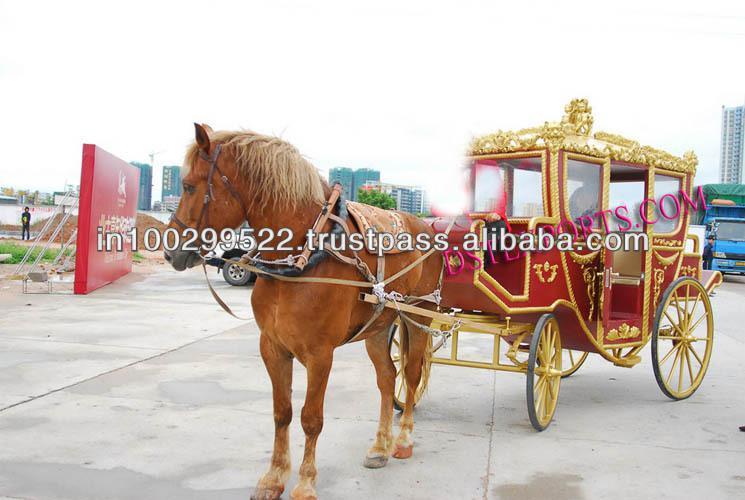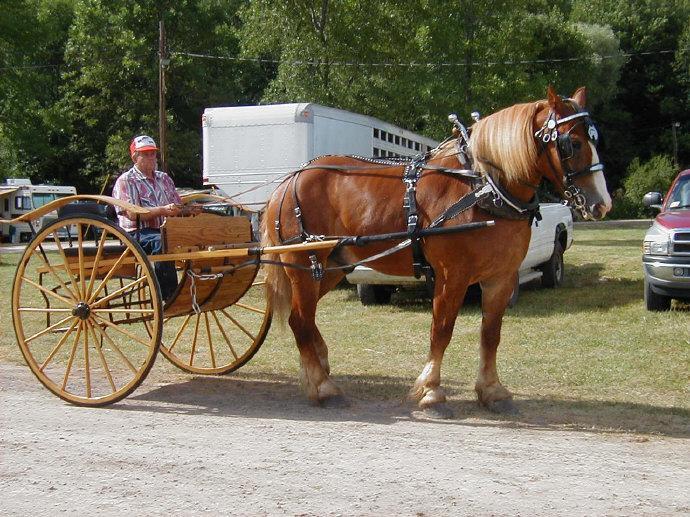The first image is the image on the left, the second image is the image on the right. Evaluate the accuracy of this statement regarding the images: "Each image shows a wagon hitched to a brown horse.". Is it true? Answer yes or no. Yes. 